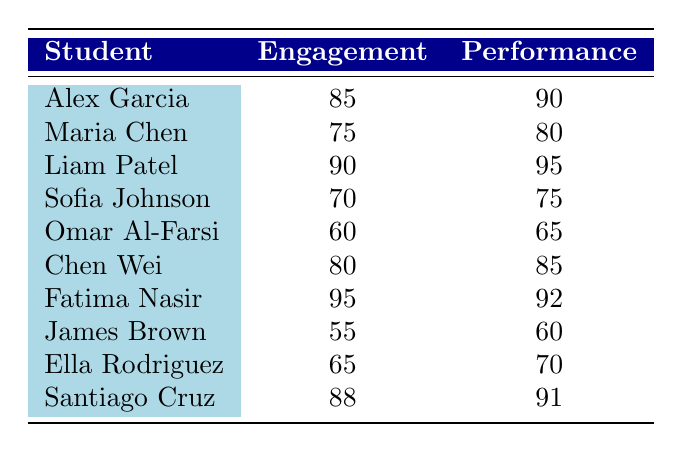What is the student engagement level of Liam Patel? By locating Liam Patel in the table, we find the corresponding engagement level listed as 90.
Answer: 90 What is the academic performance score of Chen Wei? Chen Wei's academic performance score is directly referenced in the table as 85.
Answer: 85 Which student has the lowest engagement level, and what is that level? The table shows James Brown with the lowest engagement level listed at 55.
Answer: James Brown, 55 What is the average academic performance score of the students whose engagement levels are above 80? First, identify the students with engagement levels above 80: Alex Garcia (90), Liam Patel (95), Fatima Nasir (92), Chen Wei (85), and Santiago Cruz (91). Next, sum their scores: 90 + 95 + 92 + 85 + 91 = 453. Finally, divide by the number of eligible students (5), which results in an average of 453/5 = 90.6.
Answer: 90.6 Is it true that all students with an engagement level above 80 also have an academic performance score above 80? Checking each qualifying student: Alex Garcia (90) - yes, Liam Patel (95) - yes, Fatima Nasir (92) - yes, Chen Wei (85) - yes, and Santiago Cruz (91) - yes. All students indeed have scores above 80.
Answer: Yes What is the difference between the highest and lowest engagement levels? The highest engagement level is 95 (Fatima Nasir) and the lowest is 55 (James Brown). Therefore, the difference is 95 - 55 = 40.
Answer: 40 Who has the highest academic performance score, and what is that score? By reviewing the performance scores, Liam Patel has the highest score listed, which is 95.
Answer: Liam Patel, 95 How many students have an academic performance score of 80 or below? By counting the scores of students: Maria Chen (80), Sofia Johnson (75), Omar Al-Farsi (65), James Brown (60), and Ella Rodriguez (70), there are 5 students with scores of 80 or below.
Answer: 5 